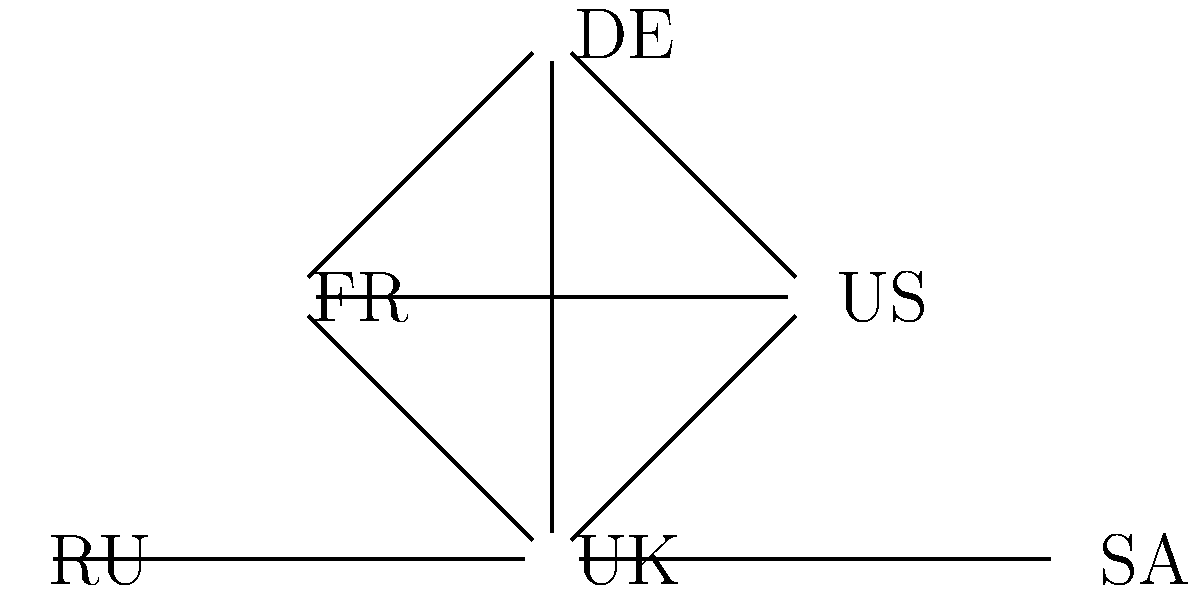Based on the network diagram of diplomatic relations, which country appears to be the most isolated in terms of alliances among the Western powers? To answer this question, we need to analyze the network diagram step by step:

1. Identify the countries in the diagram:
   UK (United Kingdom), US (United States), FR (France), DE (Germany), RU (Russia), and SA (Saudi Arabia).

2. Observe the connections between countries:
   - UK is connected to US, FR, DE, and SA
   - US is connected to UK, FR, and DE
   - FR is connected to UK, US, and DE
   - DE is connected to UK, US, and FR
   - RU is only connected to SA
   - SA is connected to UK and RU

3. Identify the Western powers:
   UK, US, FR, and DE are typically considered Western powers.

4. Analyze the connections among Western powers:
   - UK, US, FR, and DE form a complete subgraph, meaning they are all interconnected.

5. Identify the country with the least connections to Western powers:
   - RU (Russia) has no direct connections to any of the Western powers in the diagram.

Therefore, among the countries shown, Russia (RU) appears to be the most isolated in terms of alliances with Western powers.
Answer: Russia (RU) 